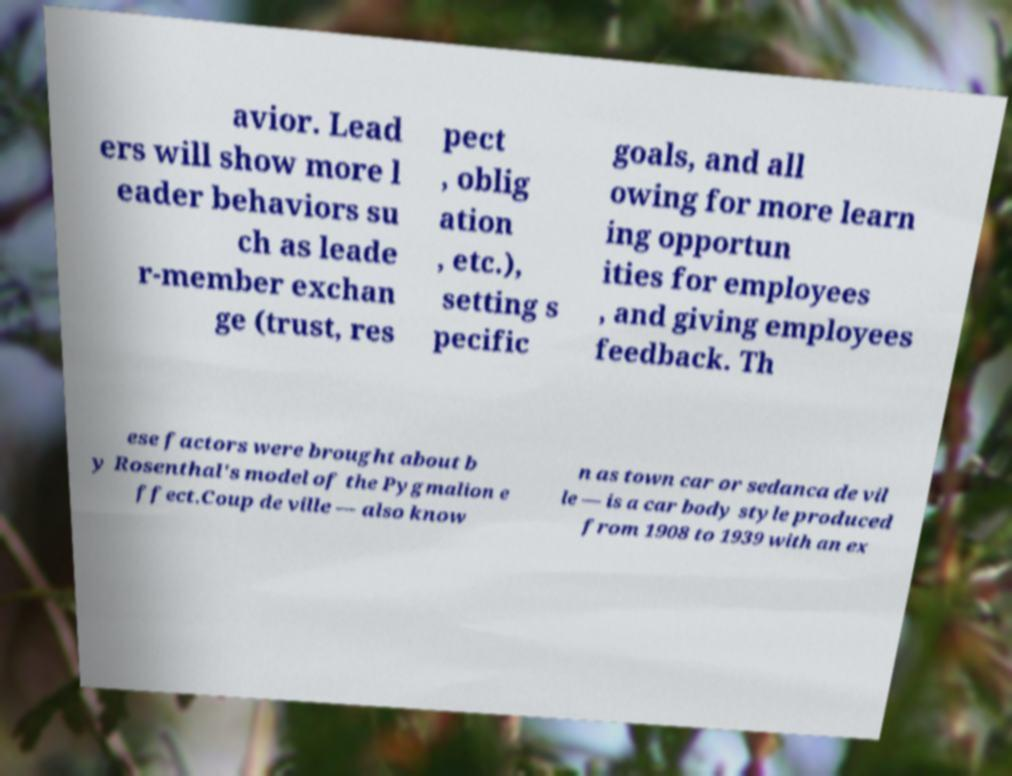Can you read and provide the text displayed in the image?This photo seems to have some interesting text. Can you extract and type it out for me? avior. Lead ers will show more l eader behaviors su ch as leade r-member exchan ge (trust, res pect , oblig ation , etc.), setting s pecific goals, and all owing for more learn ing opportun ities for employees , and giving employees feedback. Th ese factors were brought about b y Rosenthal's model of the Pygmalion e ffect.Coup de ville — also know n as town car or sedanca de vil le — is a car body style produced from 1908 to 1939 with an ex 